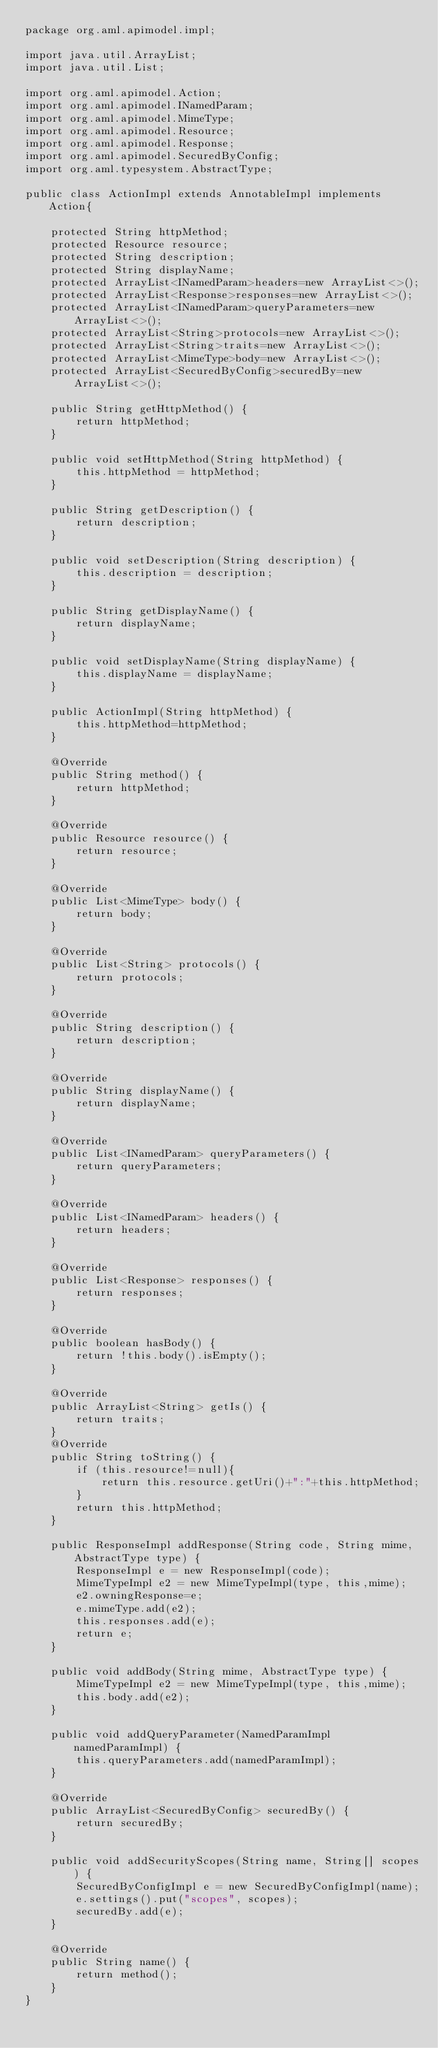<code> <loc_0><loc_0><loc_500><loc_500><_Java_>package org.aml.apimodel.impl;

import java.util.ArrayList;
import java.util.List;

import org.aml.apimodel.Action;
import org.aml.apimodel.INamedParam;
import org.aml.apimodel.MimeType;
import org.aml.apimodel.Resource;
import org.aml.apimodel.Response;
import org.aml.apimodel.SecuredByConfig;
import org.aml.typesystem.AbstractType;

public class ActionImpl extends AnnotableImpl implements Action{

	protected String httpMethod;
	protected Resource resource;
	protected String description;
	protected String displayName;
	protected ArrayList<INamedParam>headers=new ArrayList<>();
	protected ArrayList<Response>responses=new ArrayList<>();
	protected ArrayList<INamedParam>queryParameters=new ArrayList<>();
	protected ArrayList<String>protocols=new ArrayList<>();
	protected ArrayList<String>traits=new ArrayList<>();
	protected ArrayList<MimeType>body=new ArrayList<>();
	protected ArrayList<SecuredByConfig>securedBy=new ArrayList<>();
	
	public String getHttpMethod() {
		return httpMethod;
	}

	public void setHttpMethod(String httpMethod) {
		this.httpMethod = httpMethod;
	}

	public String getDescription() {
		return description;
	}

	public void setDescription(String description) {
		this.description = description;
	}

	public String getDisplayName() {
		return displayName;
	}

	public void setDisplayName(String displayName) {
		this.displayName = displayName;
	}
	
	public ActionImpl(String httpMethod) {
		this.httpMethod=httpMethod;
	}

	@Override
	public String method() {
		return httpMethod;
	}

	@Override
	public Resource resource() {
		return resource;
	}

	@Override
	public List<MimeType> body() {
		return body;
	}

	@Override
	public List<String> protocols() {
		return protocols;
	}

	@Override
	public String description() {
		return description;
	}

	@Override
	public String displayName() {
		return displayName;
	}

	@Override
	public List<INamedParam> queryParameters() {
		return queryParameters;
	}

	@Override
	public List<INamedParam> headers() {
		return headers;
	}

	@Override
	public List<Response> responses() {
		return responses;
	}

	@Override
	public boolean hasBody() {
		return !this.body().isEmpty();
	}

	@Override
	public ArrayList<String> getIs() {
		return traits;
	}
	@Override
	public String toString() {
		if (this.resource!=null){
			return this.resource.getUri()+":"+this.httpMethod;
		}
		return this.httpMethod;
	}

	public ResponseImpl addResponse(String code, String mime, AbstractType type) {
		ResponseImpl e = new ResponseImpl(code);
		MimeTypeImpl e2 = new MimeTypeImpl(type, this,mime);
		e2.owningResponse=e;
		e.mimeType.add(e2);
		this.responses.add(e);
		return e;
	}
	
	public void addBody(String mime, AbstractType type) {
		MimeTypeImpl e2 = new MimeTypeImpl(type, this,mime);
		this.body.add(e2);
	}

	public void addQueryParameter(NamedParamImpl namedParamImpl) {
		this.queryParameters.add(namedParamImpl);
	}

	@Override
	public ArrayList<SecuredByConfig> securedBy() {
		return securedBy;
	}

	public void addSecurityScopes(String name, String[] scopes) {
		SecuredByConfigImpl e = new SecuredByConfigImpl(name);
		e.settings().put("scopes", scopes);
		securedBy.add(e);	
	}

	@Override
	public String name() {
		return method();
	}
}</code> 